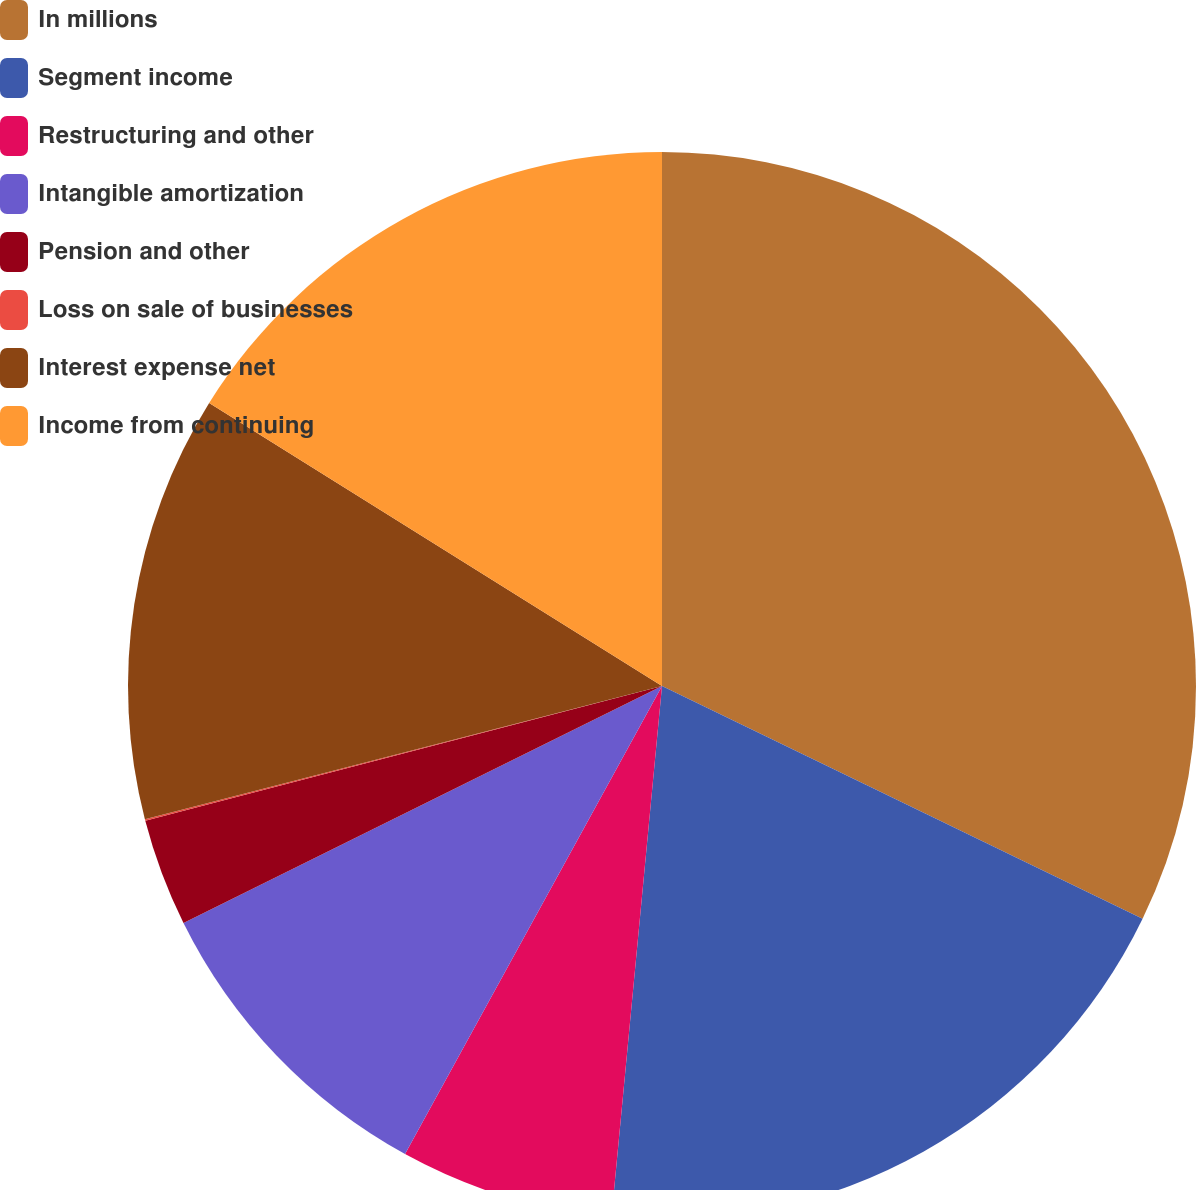Convert chart. <chart><loc_0><loc_0><loc_500><loc_500><pie_chart><fcel>In millions<fcel>Segment income<fcel>Restructuring and other<fcel>Intangible amortization<fcel>Pension and other<fcel>Loss on sale of businesses<fcel>Interest expense net<fcel>Income from continuing<nl><fcel>32.18%<fcel>19.33%<fcel>6.48%<fcel>9.69%<fcel>3.26%<fcel>0.05%<fcel>12.9%<fcel>16.11%<nl></chart> 